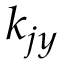<formula> <loc_0><loc_0><loc_500><loc_500>k _ { j y }</formula> 